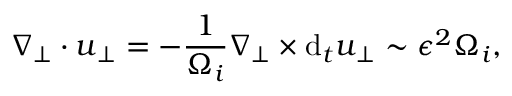<formula> <loc_0><loc_0><loc_500><loc_500>\nabla _ { \perp } \cdot u _ { \perp } = - \frac { 1 } { \Omega _ { i } } \nabla _ { \perp } \times d _ { t } u _ { \perp } \sim \epsilon ^ { 2 } \Omega _ { i } ,</formula> 